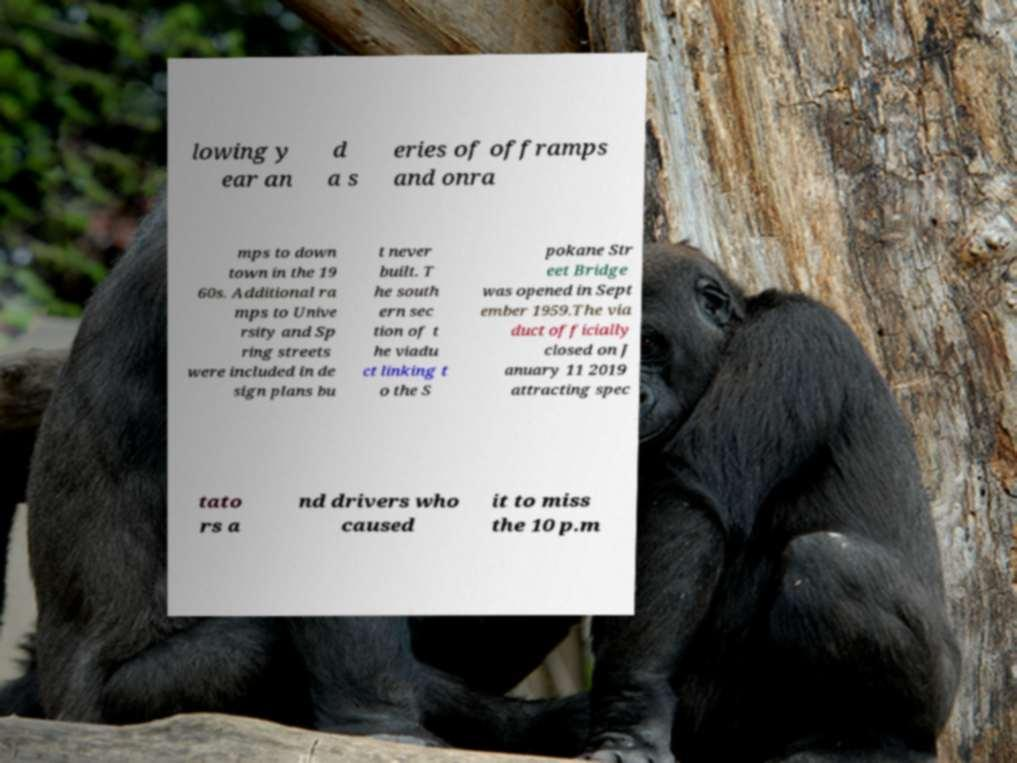For documentation purposes, I need the text within this image transcribed. Could you provide that? lowing y ear an d a s eries of offramps and onra mps to down town in the 19 60s. Additional ra mps to Unive rsity and Sp ring streets were included in de sign plans bu t never built. T he south ern sec tion of t he viadu ct linking t o the S pokane Str eet Bridge was opened in Sept ember 1959.The via duct officially closed on J anuary 11 2019 attracting spec tato rs a nd drivers who caused it to miss the 10 p.m 